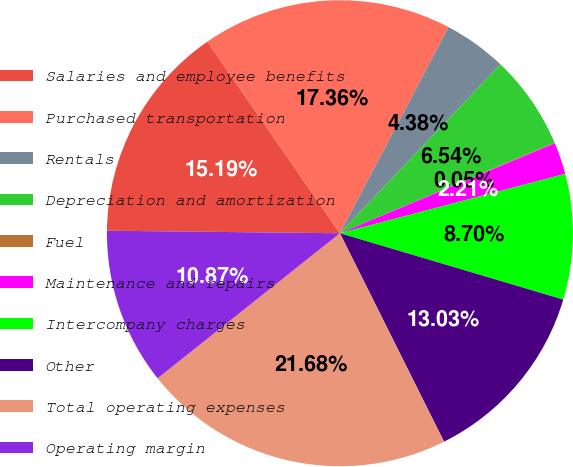<chart> <loc_0><loc_0><loc_500><loc_500><pie_chart><fcel>Salaries and employee benefits<fcel>Purchased transportation<fcel>Rentals<fcel>Depreciation and amortization<fcel>Fuel<fcel>Maintenance and repairs<fcel>Intercompany charges<fcel>Other<fcel>Total operating expenses<fcel>Operating margin<nl><fcel>15.19%<fcel>17.36%<fcel>4.38%<fcel>6.54%<fcel>0.05%<fcel>2.21%<fcel>8.7%<fcel>13.03%<fcel>21.68%<fcel>10.87%<nl></chart> 